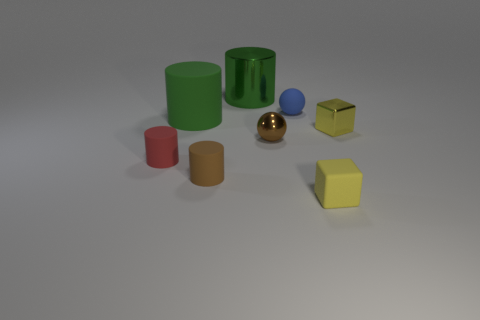Subtract 1 cylinders. How many cylinders are left? 3 Add 2 large cyan shiny cylinders. How many objects exist? 10 Subtract all brown cylinders. How many cylinders are left? 3 Subtract all green shiny cylinders. How many cylinders are left? 3 Subtract all gray cylinders. Subtract all brown cubes. How many cylinders are left? 4 Subtract all tiny blue things. Subtract all matte cylinders. How many objects are left? 4 Add 2 tiny red objects. How many tiny red objects are left? 3 Add 2 brown shiny blocks. How many brown shiny blocks exist? 2 Subtract 0 yellow cylinders. How many objects are left? 8 